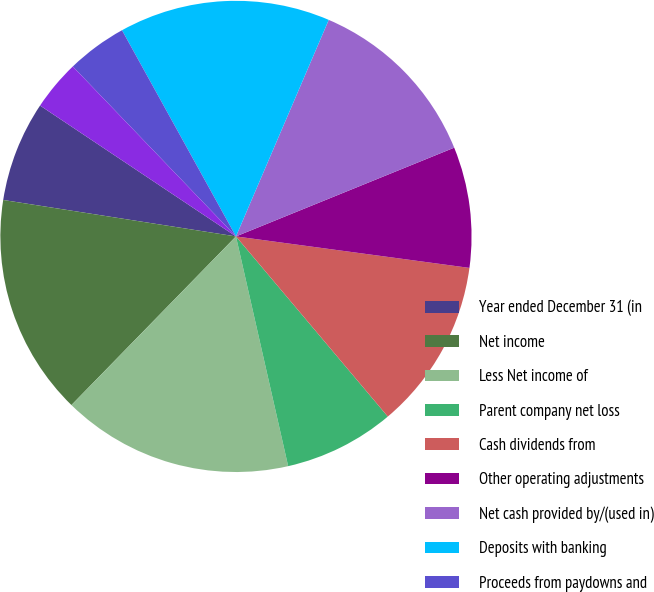Convert chart to OTSL. <chart><loc_0><loc_0><loc_500><loc_500><pie_chart><fcel>Year ended December 31 (in<fcel>Net income<fcel>Less Net income of<fcel>Parent company net loss<fcel>Cash dividends from<fcel>Other operating adjustments<fcel>Net cash provided by/(used in)<fcel>Deposits with banking<fcel>Proceeds from paydowns and<fcel>Other changes in loans net<nl><fcel>6.9%<fcel>15.17%<fcel>15.86%<fcel>7.59%<fcel>11.72%<fcel>8.28%<fcel>12.41%<fcel>14.48%<fcel>4.14%<fcel>3.45%<nl></chart> 